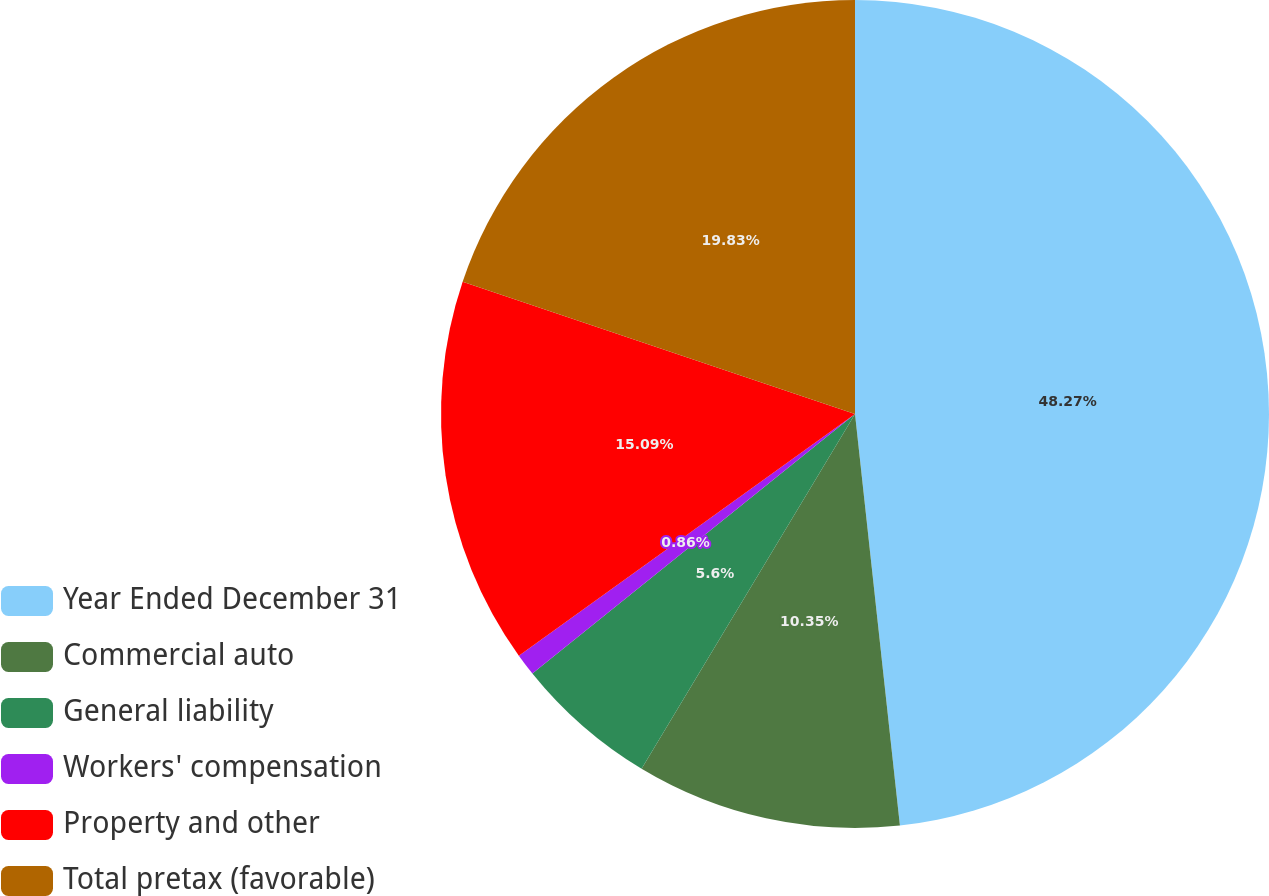Convert chart. <chart><loc_0><loc_0><loc_500><loc_500><pie_chart><fcel>Year Ended December 31<fcel>Commercial auto<fcel>General liability<fcel>Workers' compensation<fcel>Property and other<fcel>Total pretax (favorable)<nl><fcel>48.27%<fcel>10.35%<fcel>5.6%<fcel>0.86%<fcel>15.09%<fcel>19.83%<nl></chart> 